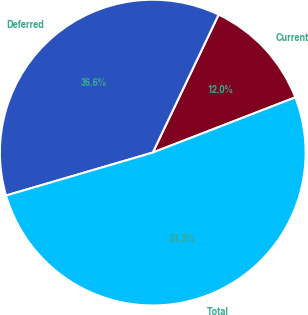<chart> <loc_0><loc_0><loc_500><loc_500><pie_chart><fcel>Current<fcel>Deferred<fcel>Total<nl><fcel>12.03%<fcel>36.62%<fcel>51.35%<nl></chart> 